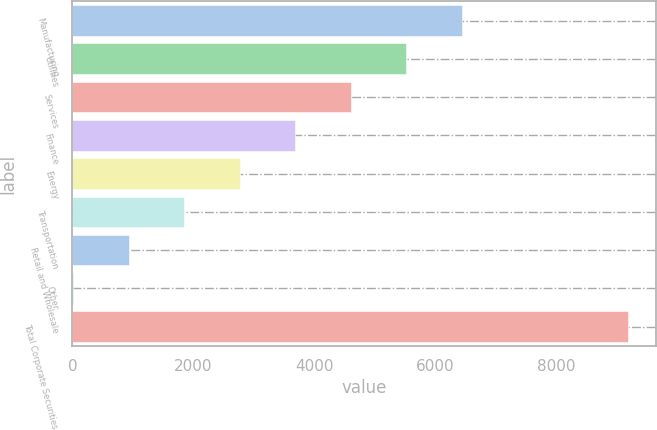<chart> <loc_0><loc_0><loc_500><loc_500><bar_chart><fcel>Manufacturing<fcel>Utilities<fcel>Services<fcel>Finance<fcel>Energy<fcel>Transportation<fcel>Retail and Wholesale<fcel>Other<fcel>Total Corporate Securities<nl><fcel>6444.7<fcel>5525.6<fcel>4606.5<fcel>3687.4<fcel>2768.3<fcel>1849.2<fcel>930.1<fcel>11<fcel>9202<nl></chart> 